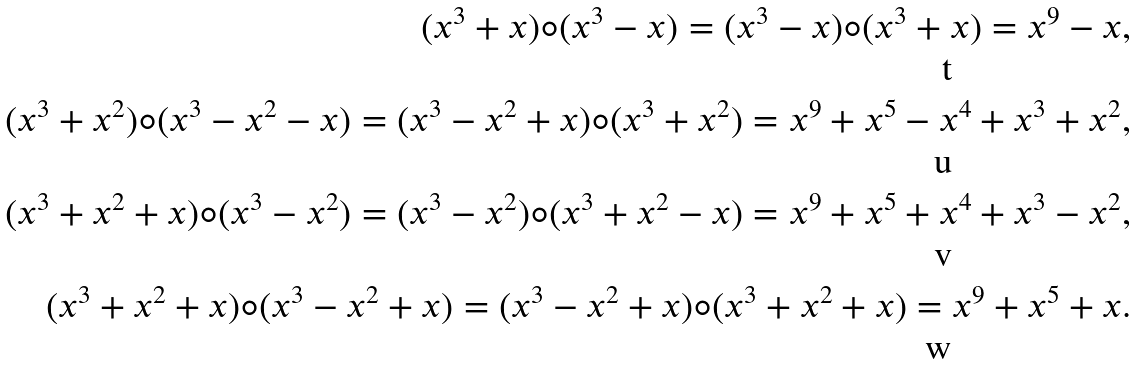<formula> <loc_0><loc_0><loc_500><loc_500>( x ^ { 3 } + x ) \circ ( x ^ { 3 } - x ) = ( x ^ { 3 } - x ) \circ ( x ^ { 3 } + x ) = x ^ { 9 } - x , \\ ( x ^ { 3 } + x ^ { 2 } ) \circ ( x ^ { 3 } - x ^ { 2 } - x ) = ( x ^ { 3 } - x ^ { 2 } + x ) \circ ( x ^ { 3 } + x ^ { 2 } ) = x ^ { 9 } + x ^ { 5 } - x ^ { 4 } + x ^ { 3 } + x ^ { 2 } , \\ ( x ^ { 3 } + x ^ { 2 } + x ) \circ ( x ^ { 3 } - x ^ { 2 } ) = ( x ^ { 3 } - x ^ { 2 } ) \circ ( x ^ { 3 } + x ^ { 2 } - x ) = x ^ { 9 } + x ^ { 5 } + x ^ { 4 } + x ^ { 3 } - x ^ { 2 } , \\ ( x ^ { 3 } + x ^ { 2 } + x ) \circ ( x ^ { 3 } - x ^ { 2 } + x ) = ( x ^ { 3 } - x ^ { 2 } + x ) \circ ( x ^ { 3 } + x ^ { 2 } + x ) = x ^ { 9 } + x ^ { 5 } + x .</formula> 